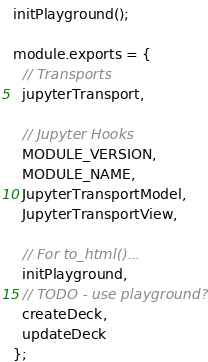<code> <loc_0><loc_0><loc_500><loc_500><_JavaScript_>initPlayground();

module.exports = {
  // Transports
  jupyterTransport,

  // Jupyter Hooks
  MODULE_VERSION,
  MODULE_NAME,
  JupyterTransportModel,
  JupyterTransportView,

  // For to_html()...
  initPlayground,
  // TODO - use playground?
  createDeck,
  updateDeck
};
</code> 